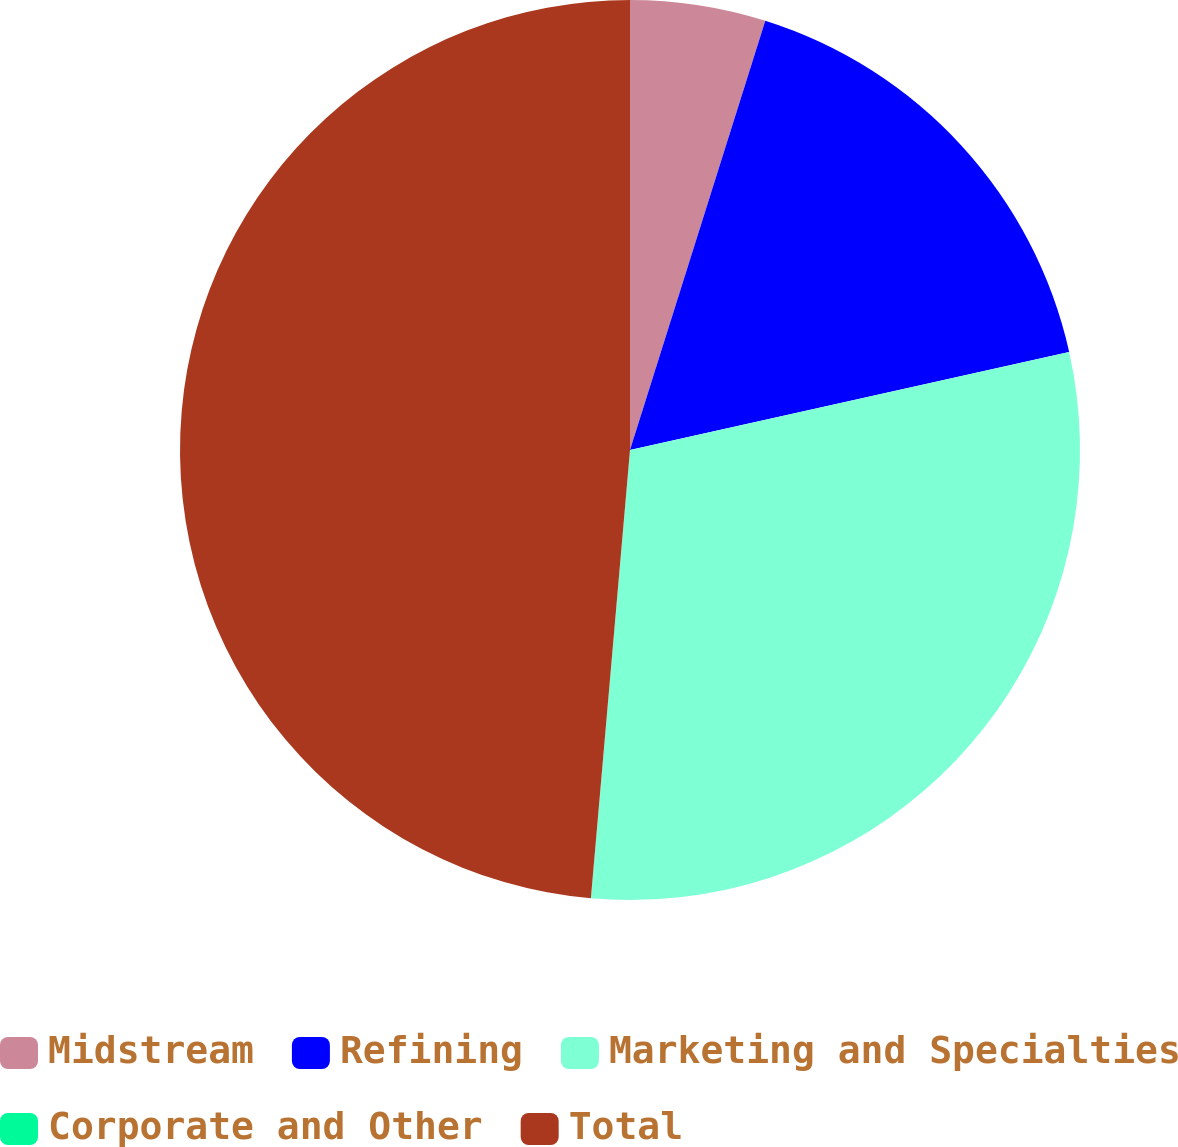Convert chart. <chart><loc_0><loc_0><loc_500><loc_500><pie_chart><fcel>Midstream<fcel>Refining<fcel>Marketing and Specialties<fcel>Corporate and Other<fcel>Total<nl><fcel>4.86%<fcel>16.64%<fcel>29.88%<fcel>0.0%<fcel>48.61%<nl></chart> 